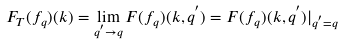Convert formula to latex. <formula><loc_0><loc_0><loc_500><loc_500>F _ { T } ( f _ { q } ) ( k ) = \lim _ { q ^ { ^ { \prime } } \rightarrow q } F ( f _ { q } ) ( k , q ^ { ^ { \prime } } ) = F ( f _ { q } ) ( k , q ^ { ^ { \prime } } ) { | } _ { q ^ { ^ { \prime } } = q }</formula> 